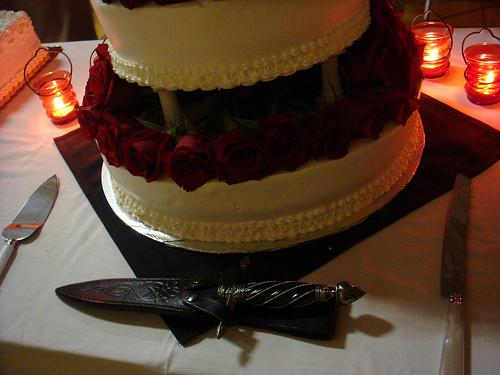Question: what are between the cake layers?
Choices:
A. Fudge.
B. Icing.
C. Roses.
D. Sprinkles.
Answer with the letter. Answer: C Question: who will cut the cake?
Choices:
A. The bride and groom.
B. The mom.
C. The birthday girl.
D. The aunt.
Answer with the letter. Answer: A Question: how many candles are in the photo?
Choices:
A. Two.
B. Three.
C. One.
D. FOur.
Answer with the letter. Answer: B Question: why are there candles around the cake?
Choices:
A. For ambiance.
B. To be blown out.
C. To signify age.
D. For decoration.
Answer with the letter. Answer: A 